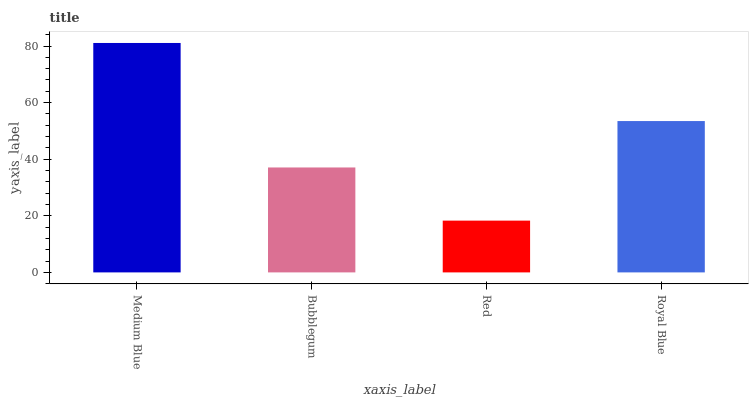Is Red the minimum?
Answer yes or no. Yes. Is Medium Blue the maximum?
Answer yes or no. Yes. Is Bubblegum the minimum?
Answer yes or no. No. Is Bubblegum the maximum?
Answer yes or no. No. Is Medium Blue greater than Bubblegum?
Answer yes or no. Yes. Is Bubblegum less than Medium Blue?
Answer yes or no. Yes. Is Bubblegum greater than Medium Blue?
Answer yes or no. No. Is Medium Blue less than Bubblegum?
Answer yes or no. No. Is Royal Blue the high median?
Answer yes or no. Yes. Is Bubblegum the low median?
Answer yes or no. Yes. Is Red the high median?
Answer yes or no. No. Is Medium Blue the low median?
Answer yes or no. No. 